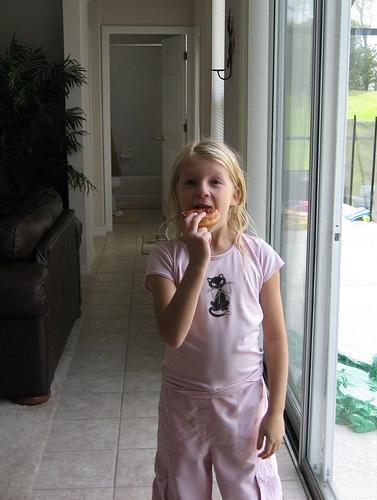How many people can be seen?
Give a very brief answer. 1. 